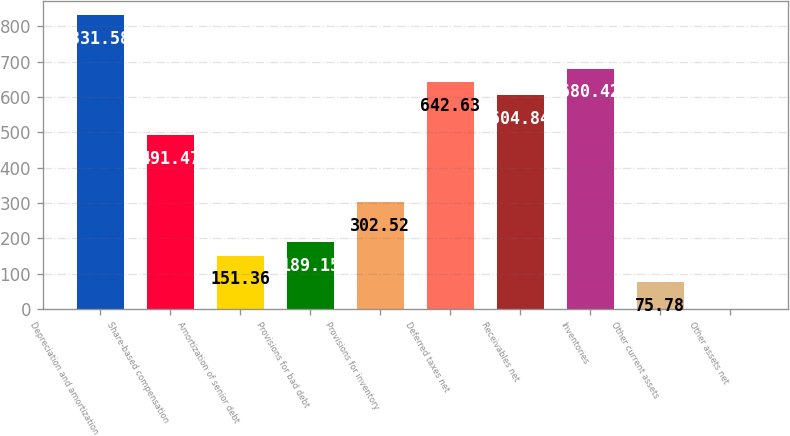<chart> <loc_0><loc_0><loc_500><loc_500><bar_chart><fcel>Depreciation and amortization<fcel>Share-based compensation<fcel>Amortization of senior debt<fcel>Provisions for bad debt<fcel>Provisions for inventory<fcel>Deferred taxes net<fcel>Receivables net<fcel>Inventories<fcel>Other current assets<fcel>Other assets net<nl><fcel>831.58<fcel>491.47<fcel>151.36<fcel>189.15<fcel>302.52<fcel>642.63<fcel>604.84<fcel>680.42<fcel>75.78<fcel>0.2<nl></chart> 